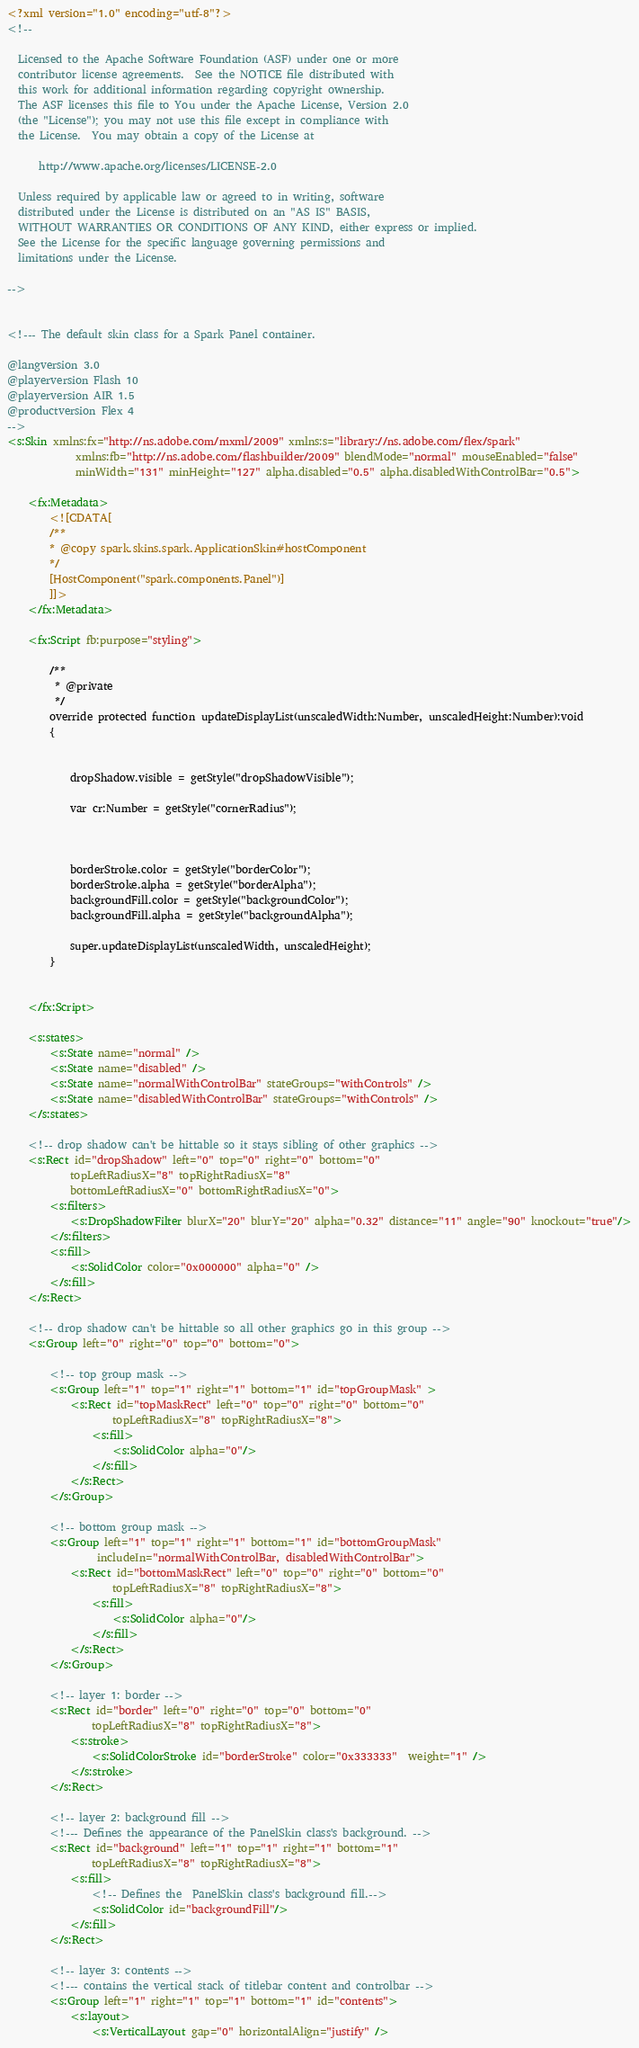Convert code to text. <code><loc_0><loc_0><loc_500><loc_500><_XML_><?xml version="1.0" encoding="utf-8"?>
<!--

  Licensed to the Apache Software Foundation (ASF) under one or more
  contributor license agreements.  See the NOTICE file distributed with
  this work for additional information regarding copyright ownership.
  The ASF licenses this file to You under the Apache License, Version 2.0
  (the "License"); you may not use this file except in compliance with
  the License.  You may obtain a copy of the License at

      http://www.apache.org/licenses/LICENSE-2.0

  Unless required by applicable law or agreed to in writing, software
  distributed under the License is distributed on an "AS IS" BASIS,
  WITHOUT WARRANTIES OR CONDITIONS OF ANY KIND, either express or implied.
  See the License for the specific language governing permissions and
  limitations under the License.

-->


<!--- The default skin class for a Spark Panel container.  

@langversion 3.0
@playerversion Flash 10
@playerversion AIR 1.5
@productversion Flex 4
-->
<s:Skin xmlns:fx="http://ns.adobe.com/mxml/2009" xmlns:s="library://ns.adobe.com/flex/spark" 
			 xmlns:fb="http://ns.adobe.com/flashbuilder/2009" blendMode="normal" mouseEnabled="false" 
			 minWidth="131" minHeight="127" alpha.disabled="0.5" alpha.disabledWithControlBar="0.5">
	
	<fx:Metadata>
		<![CDATA[ 
		/** 
		* @copy spark.skins.spark.ApplicationSkin#hostComponent
		*/
		[HostComponent("spark.components.Panel")]
		]]>
	</fx:Metadata> 
	
	<fx:Script fb:purpose="styling">
		
		/**
		 * @private
		 */
		override protected function updateDisplayList(unscaledWidth:Number, unscaledHeight:Number):void
		{
			
			
			dropShadow.visible = getStyle("dropShadowVisible");
			
			var cr:Number = getStyle("cornerRadius");
			
			
			
			borderStroke.color = getStyle("borderColor");
			borderStroke.alpha = getStyle("borderAlpha");
			backgroundFill.color = getStyle("backgroundColor");
			backgroundFill.alpha = getStyle("backgroundAlpha");
			
			super.updateDisplayList(unscaledWidth, unscaledHeight);
		}
		
		
	</fx:Script>
	
	<s:states>
		<s:State name="normal" />
		<s:State name="disabled" />
		<s:State name="normalWithControlBar" stateGroups="withControls" />
		<s:State name="disabledWithControlBar" stateGroups="withControls" />
	</s:states>
	
	<!-- drop shadow can't be hittable so it stays sibling of other graphics -->
	<s:Rect id="dropShadow" left="0" top="0" right="0" bottom="0" 
			topLeftRadiusX="8" topRightRadiusX="8" 
			bottomLeftRadiusX="0" bottomRightRadiusX="0">
		<s:filters>
			<s:DropShadowFilter blurX="20" blurY="20" alpha="0.32" distance="11" angle="90" knockout="true"/>
		</s:filters>
		<s:fill>
			<s:SolidColor color="0x000000" alpha="0" />
		</s:fill>
	</s:Rect>
	
	<!-- drop shadow can't be hittable so all other graphics go in this group -->
	<s:Group left="0" right="0" top="0" bottom="0">
		
		<!-- top group mask -->
		<s:Group left="1" top="1" right="1" bottom="1" id="topGroupMask" >
			<s:Rect id="topMaskRect" left="0" top="0" right="0" bottom="0"
					topLeftRadiusX="8" topRightRadiusX="8">
				<s:fill>
					<s:SolidColor alpha="0"/>
				</s:fill>
			</s:Rect>
		</s:Group>
		
		<!-- bottom group mask -->
		<s:Group left="1" top="1" right="1" bottom="1" id="bottomGroupMask" 
				 includeIn="normalWithControlBar, disabledWithControlBar">
			<s:Rect id="bottomMaskRect" left="0" top="0" right="0" bottom="0"
					topLeftRadiusX="8" topRightRadiusX="8">
				<s:fill>
					<s:SolidColor alpha="0"/>
				</s:fill>
			</s:Rect>
		</s:Group>
		
		<!-- layer 1: border -->
		<s:Rect id="border" left="0" right="0" top="0" bottom="0"
				topLeftRadiusX="8" topRightRadiusX="8">
			<s:stroke>
				<s:SolidColorStroke id="borderStroke" color="0x333333"  weight="1" />
			</s:stroke>
		</s:Rect>
		
		<!-- layer 2: background fill -->
		<!--- Defines the appearance of the PanelSkin class's background. -->
		<s:Rect id="background" left="1" top="1" right="1" bottom="1"
				topLeftRadiusX="8" topRightRadiusX="8">
			<s:fill>
				<!-- Defines the  PanelSkin class's background fill.-->
				<s:SolidColor id="backgroundFill"/>
			</s:fill>
		</s:Rect>
		
		<!-- layer 3: contents -->
		<!--- contains the vertical stack of titlebar content and controlbar -->
		<s:Group left="1" right="1" top="1" bottom="1" id="contents">
			<s:layout>
				<s:VerticalLayout gap="0" horizontalAlign="justify" /></code> 